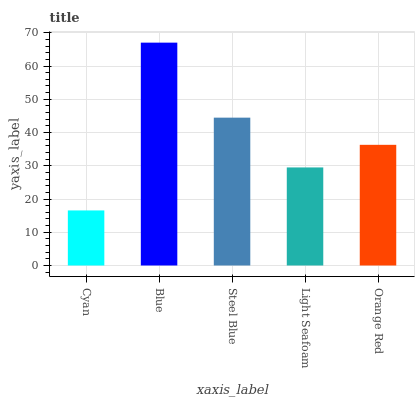Is Steel Blue the minimum?
Answer yes or no. No. Is Steel Blue the maximum?
Answer yes or no. No. Is Blue greater than Steel Blue?
Answer yes or no. Yes. Is Steel Blue less than Blue?
Answer yes or no. Yes. Is Steel Blue greater than Blue?
Answer yes or no. No. Is Blue less than Steel Blue?
Answer yes or no. No. Is Orange Red the high median?
Answer yes or no. Yes. Is Orange Red the low median?
Answer yes or no. Yes. Is Light Seafoam the high median?
Answer yes or no. No. Is Cyan the low median?
Answer yes or no. No. 